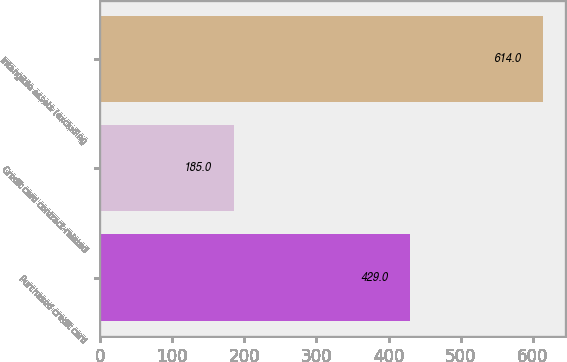Convert chart. <chart><loc_0><loc_0><loc_500><loc_500><bar_chart><fcel>Purchased credit card<fcel>Credit card contract-related<fcel>Intangible assets (excluding<nl><fcel>429<fcel>185<fcel>614<nl></chart> 